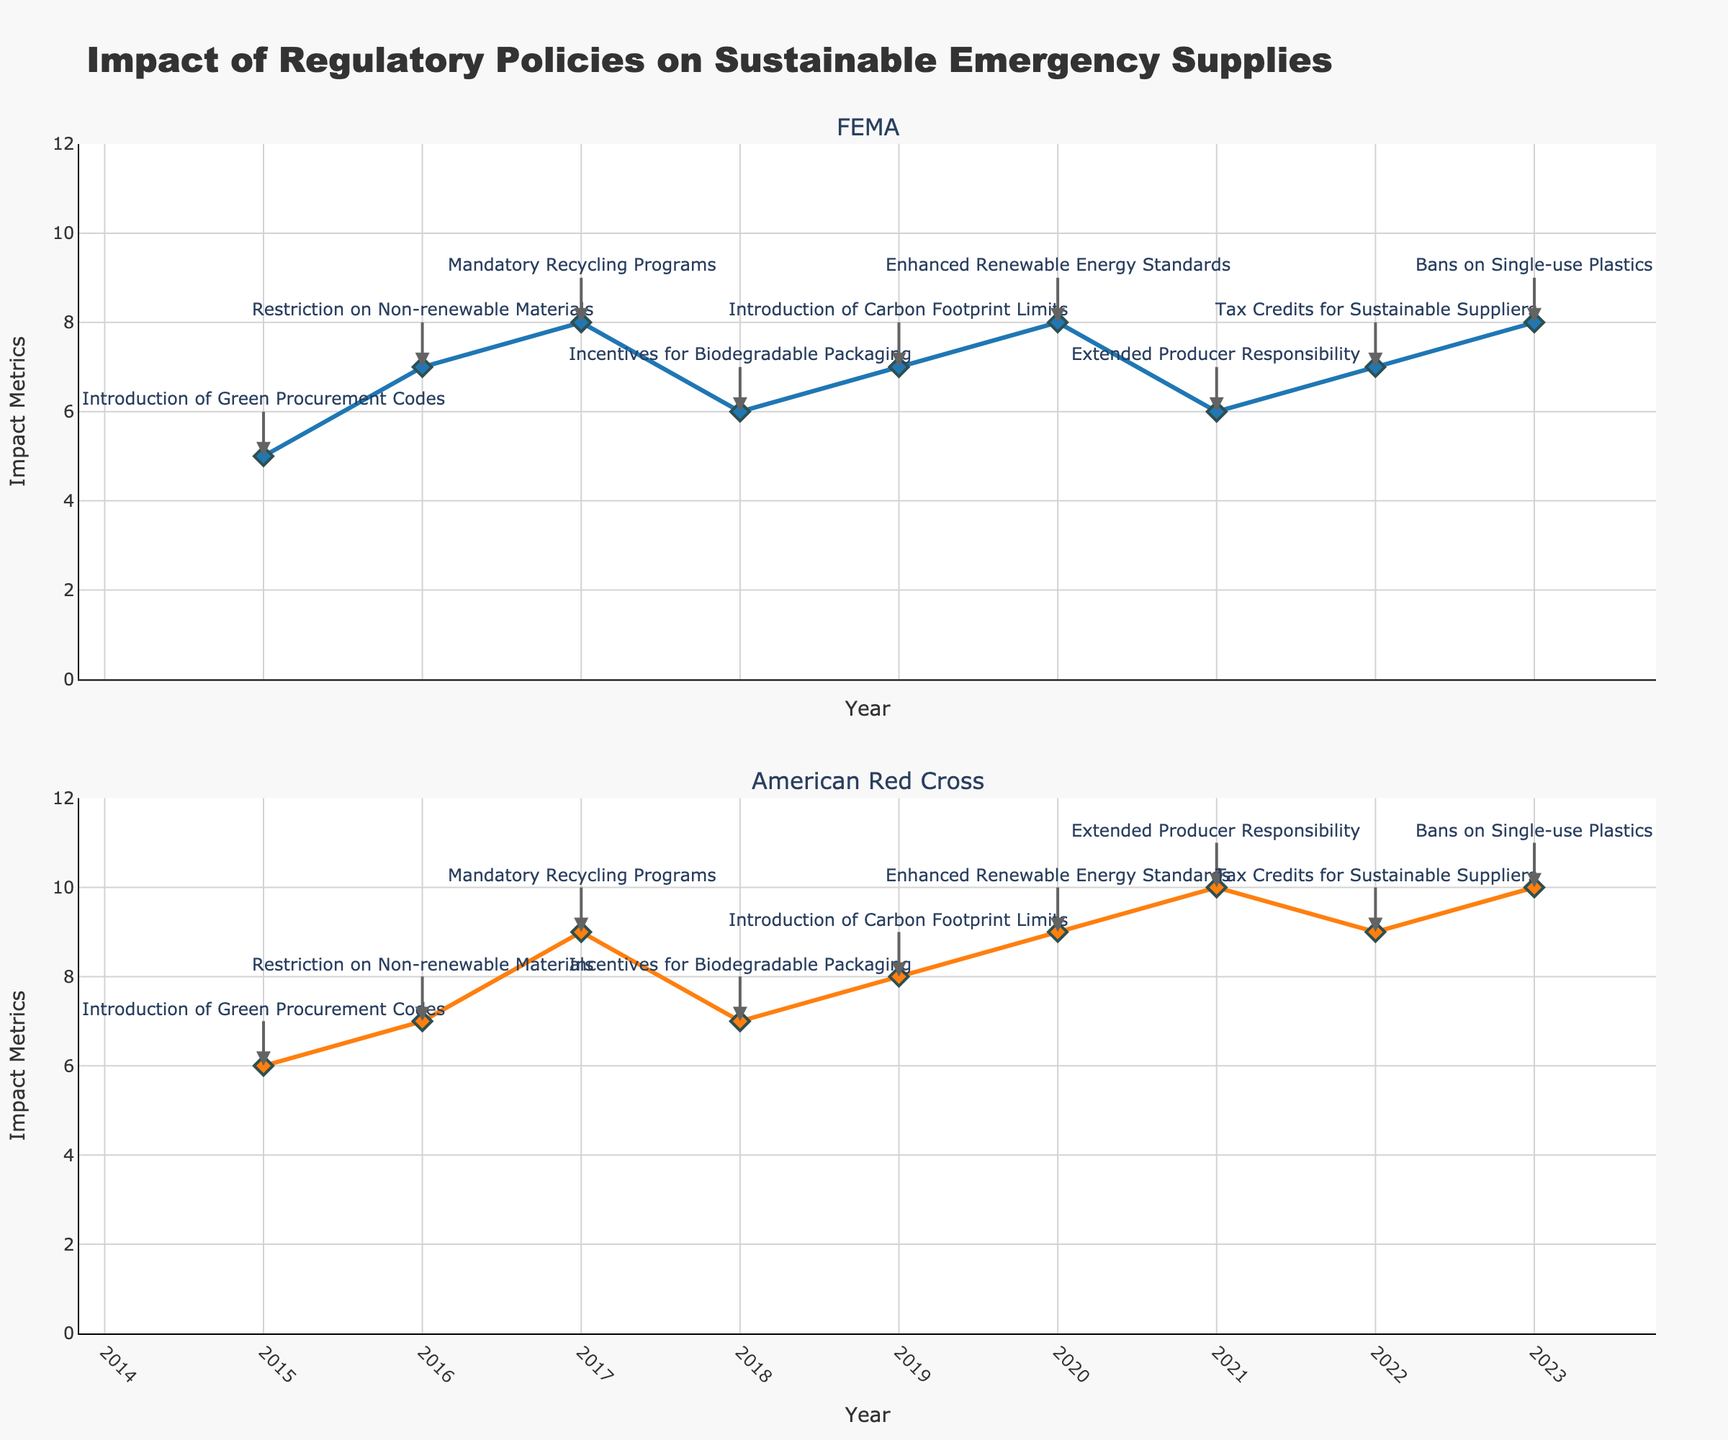How many regulatory policies are annotated in the plot for FEMA? The figure contains a series of annotations indicating various regulatory policies for FEMA. Counting all the annotations in the FEMA subplot gives us the number of policies.
Answer: 9 Which year shows the highest impact metric for FEMA? By analyzing the trend line for FEMA in the time series plot, we observe the highest point on the y-axis and note the corresponding year on the x-axis.
Answer: 2017 How does the overall impact trend for American Red Cross compare to FEMA from 2015 to 2023? We compare the lines plotted for both FEMA and American Red Cross from 2015 to 2023. The American Red Cross generally shows a higher and increasing trend in impact metrics compared to FEMA, with more peaks and an overall increasing pattern.
Answer: American Red Cross shows a higher and increasing trend What policy change happened in 2021 and how did it impact the American Red Cross? We look for the annotation in the year 2021 on the American Red Cross subplot, which indicates the policy. Then we observe the impact metric value for that year.
Answer: Extended Producer Responsibility, 10 Which organization showed a more significant impact from the "Restriction on Non-renewable Materials" policy in 2016? We look at the plot for both organizations in 2016, particularly at the y-axis values next to the annotation "Restriction on Non-renewable Materials." Both values (FEMA and American Red Cross) are observed and compared.
Answer: Both showed an impact of 7 What was the impact metric for FEMA in 2022? We find the plotted point for FEMA in the year 2022 and read the value off the y-axis.
Answer: 7 By how much did the impact metric change for FEMA from 2018 to 2019? We find the impact metric values for FEMA in 2018 and 2019. Subtract the 2018 value from the 2019 value to find the difference.
Answer: 1 What is the mean impact metric for American Red Cross from 2015 to 2023? We look at the impact metrics for American Red Cross over the years 2015 to 2023: 6, 7, 9, 7, 8, 9, 10, 9, 10. Summing these values and dividing by the number of years (9) gives us the mean.
Answer: 8.33 Which organization saw a decrease in impact metrics due to the policy change "Extended Producer Responsibility" in 2021? Reviewing the plot and annotations around the year 2021, we compare the impact metrics immediately before and after this policy for both organizations. FEMA shows a decrease.
Answer: FEMA 